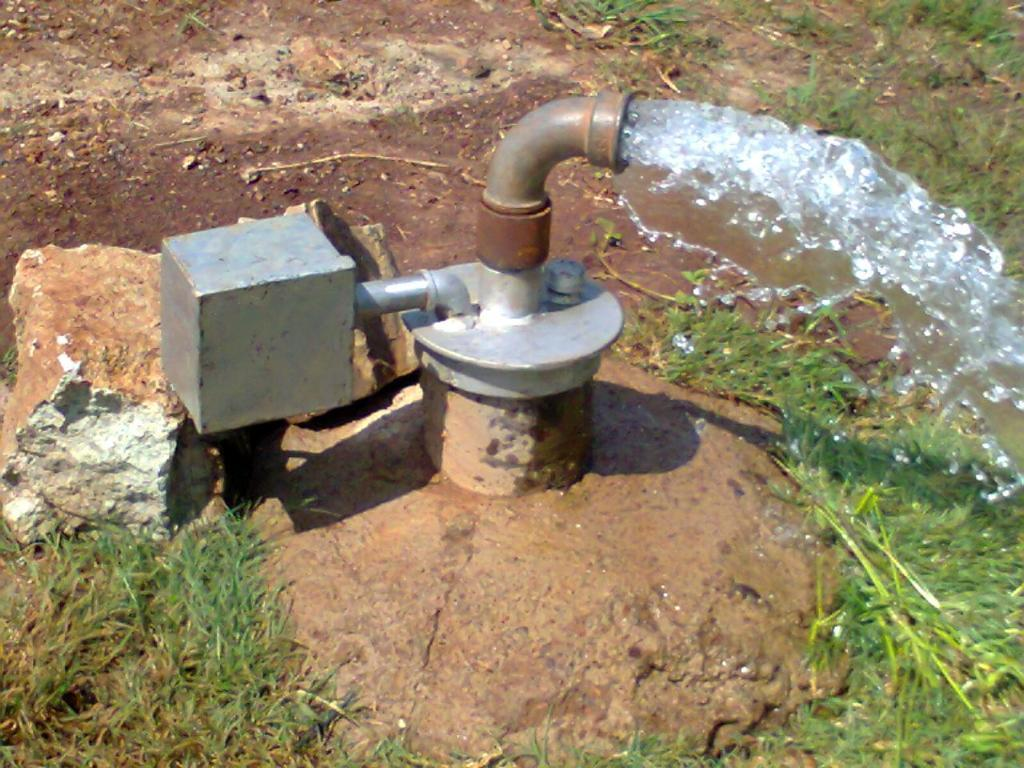What is the main object in the image? There is a pipe in the image. What is present alongside the pipe? There is water and grass in the image. What type of pancake is being cooked on the pipe in the image? There is no pancake present in the image; it features a pipe, water, and grass. What camping equipment can be seen in the image? There is no camping equipment present in the image; it features a pipe, water, and grass. 